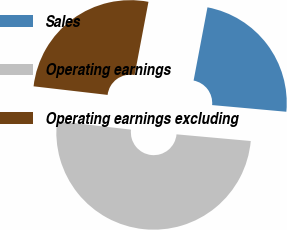Convert chart to OTSL. <chart><loc_0><loc_0><loc_500><loc_500><pie_chart><fcel>Sales<fcel>Operating earnings<fcel>Operating earnings excluding<nl><fcel>23.45%<fcel>50.41%<fcel>26.14%<nl></chart> 